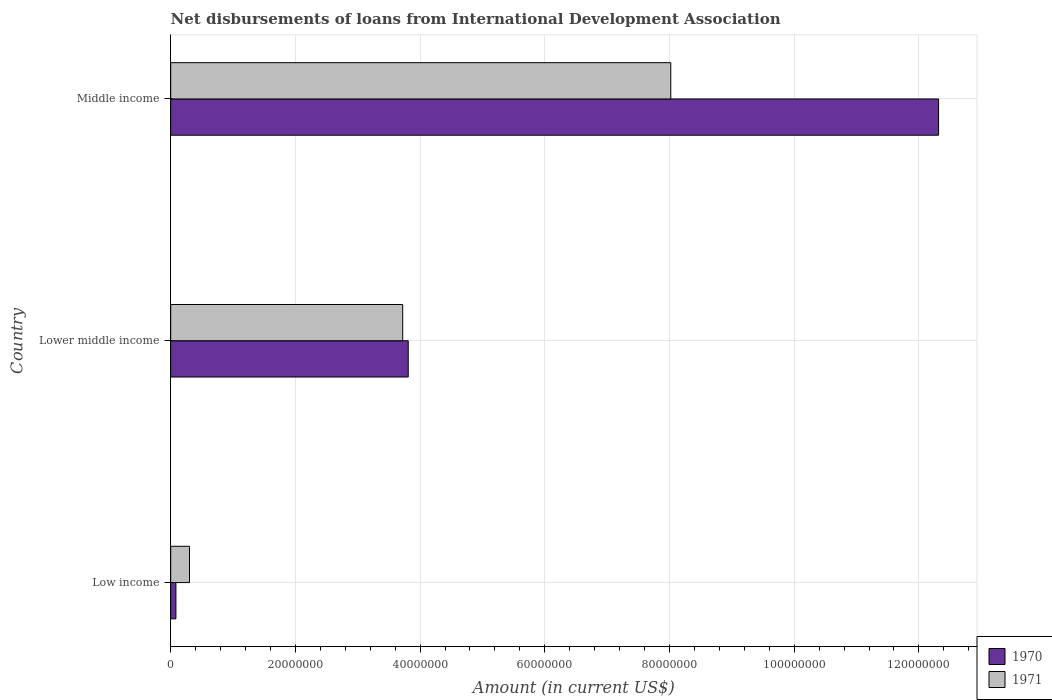How many different coloured bars are there?
Give a very brief answer. 2. How many groups of bars are there?
Your answer should be compact. 3. Are the number of bars per tick equal to the number of legend labels?
Your response must be concise. Yes. How many bars are there on the 3rd tick from the top?
Keep it short and to the point. 2. How many bars are there on the 2nd tick from the bottom?
Provide a succinct answer. 2. What is the amount of loans disbursed in 1971 in Lower middle income?
Provide a succinct answer. 3.72e+07. Across all countries, what is the maximum amount of loans disbursed in 1971?
Provide a short and direct response. 8.02e+07. Across all countries, what is the minimum amount of loans disbursed in 1970?
Provide a short and direct response. 8.35e+05. In which country was the amount of loans disbursed in 1971 maximum?
Ensure brevity in your answer.  Middle income. What is the total amount of loans disbursed in 1970 in the graph?
Your answer should be compact. 1.62e+08. What is the difference between the amount of loans disbursed in 1971 in Lower middle income and that in Middle income?
Give a very brief answer. -4.30e+07. What is the difference between the amount of loans disbursed in 1971 in Low income and the amount of loans disbursed in 1970 in Middle income?
Provide a succinct answer. -1.20e+08. What is the average amount of loans disbursed in 1971 per country?
Offer a very short reply. 4.01e+07. What is the difference between the amount of loans disbursed in 1970 and amount of loans disbursed in 1971 in Lower middle income?
Keep it short and to the point. 8.88e+05. In how many countries, is the amount of loans disbursed in 1971 greater than 40000000 US$?
Provide a succinct answer. 1. What is the ratio of the amount of loans disbursed in 1971 in Low income to that in Middle income?
Offer a very short reply. 0.04. Is the amount of loans disbursed in 1970 in Lower middle income less than that in Middle income?
Keep it short and to the point. Yes. What is the difference between the highest and the second highest amount of loans disbursed in 1971?
Ensure brevity in your answer.  4.30e+07. What is the difference between the highest and the lowest amount of loans disbursed in 1970?
Ensure brevity in your answer.  1.22e+08. In how many countries, is the amount of loans disbursed in 1970 greater than the average amount of loans disbursed in 1970 taken over all countries?
Offer a very short reply. 1. Is the sum of the amount of loans disbursed in 1970 in Low income and Middle income greater than the maximum amount of loans disbursed in 1971 across all countries?
Your answer should be compact. Yes. What does the 1st bar from the top in Middle income represents?
Give a very brief answer. 1971. How many bars are there?
Keep it short and to the point. 6. Are all the bars in the graph horizontal?
Ensure brevity in your answer.  Yes. What is the difference between two consecutive major ticks on the X-axis?
Make the answer very short. 2.00e+07. Are the values on the major ticks of X-axis written in scientific E-notation?
Your answer should be compact. No. Does the graph contain any zero values?
Provide a short and direct response. No. Does the graph contain grids?
Ensure brevity in your answer.  Yes. Where does the legend appear in the graph?
Your answer should be very brief. Bottom right. How many legend labels are there?
Offer a terse response. 2. What is the title of the graph?
Offer a terse response. Net disbursements of loans from International Development Association. What is the Amount (in current US$) of 1970 in Low income?
Provide a succinct answer. 8.35e+05. What is the Amount (in current US$) in 1971 in Low income?
Your answer should be very brief. 3.02e+06. What is the Amount (in current US$) of 1970 in Lower middle income?
Give a very brief answer. 3.81e+07. What is the Amount (in current US$) of 1971 in Lower middle income?
Make the answer very short. 3.72e+07. What is the Amount (in current US$) in 1970 in Middle income?
Offer a terse response. 1.23e+08. What is the Amount (in current US$) of 1971 in Middle income?
Give a very brief answer. 8.02e+07. Across all countries, what is the maximum Amount (in current US$) in 1970?
Offer a very short reply. 1.23e+08. Across all countries, what is the maximum Amount (in current US$) in 1971?
Provide a succinct answer. 8.02e+07. Across all countries, what is the minimum Amount (in current US$) in 1970?
Your answer should be very brief. 8.35e+05. Across all countries, what is the minimum Amount (in current US$) of 1971?
Ensure brevity in your answer.  3.02e+06. What is the total Amount (in current US$) of 1970 in the graph?
Keep it short and to the point. 1.62e+08. What is the total Amount (in current US$) of 1971 in the graph?
Your answer should be very brief. 1.20e+08. What is the difference between the Amount (in current US$) in 1970 in Low income and that in Lower middle income?
Ensure brevity in your answer.  -3.73e+07. What is the difference between the Amount (in current US$) of 1971 in Low income and that in Lower middle income?
Provide a short and direct response. -3.42e+07. What is the difference between the Amount (in current US$) in 1970 in Low income and that in Middle income?
Provide a succinct answer. -1.22e+08. What is the difference between the Amount (in current US$) in 1971 in Low income and that in Middle income?
Provide a succinct answer. -7.72e+07. What is the difference between the Amount (in current US$) of 1970 in Lower middle income and that in Middle income?
Offer a very short reply. -8.51e+07. What is the difference between the Amount (in current US$) in 1971 in Lower middle income and that in Middle income?
Ensure brevity in your answer.  -4.30e+07. What is the difference between the Amount (in current US$) in 1970 in Low income and the Amount (in current US$) in 1971 in Lower middle income?
Offer a very short reply. -3.64e+07. What is the difference between the Amount (in current US$) of 1970 in Low income and the Amount (in current US$) of 1971 in Middle income?
Provide a short and direct response. -7.94e+07. What is the difference between the Amount (in current US$) in 1970 in Lower middle income and the Amount (in current US$) in 1971 in Middle income?
Keep it short and to the point. -4.21e+07. What is the average Amount (in current US$) of 1970 per country?
Your response must be concise. 5.40e+07. What is the average Amount (in current US$) of 1971 per country?
Ensure brevity in your answer.  4.01e+07. What is the difference between the Amount (in current US$) of 1970 and Amount (in current US$) of 1971 in Low income?
Your response must be concise. -2.18e+06. What is the difference between the Amount (in current US$) of 1970 and Amount (in current US$) of 1971 in Lower middle income?
Your response must be concise. 8.88e+05. What is the difference between the Amount (in current US$) of 1970 and Amount (in current US$) of 1971 in Middle income?
Your response must be concise. 4.30e+07. What is the ratio of the Amount (in current US$) in 1970 in Low income to that in Lower middle income?
Your answer should be very brief. 0.02. What is the ratio of the Amount (in current US$) of 1971 in Low income to that in Lower middle income?
Your answer should be compact. 0.08. What is the ratio of the Amount (in current US$) of 1970 in Low income to that in Middle income?
Your response must be concise. 0.01. What is the ratio of the Amount (in current US$) in 1971 in Low income to that in Middle income?
Provide a succinct answer. 0.04. What is the ratio of the Amount (in current US$) of 1970 in Lower middle income to that in Middle income?
Offer a very short reply. 0.31. What is the ratio of the Amount (in current US$) of 1971 in Lower middle income to that in Middle income?
Your answer should be compact. 0.46. What is the difference between the highest and the second highest Amount (in current US$) in 1970?
Keep it short and to the point. 8.51e+07. What is the difference between the highest and the second highest Amount (in current US$) of 1971?
Offer a terse response. 4.30e+07. What is the difference between the highest and the lowest Amount (in current US$) in 1970?
Your response must be concise. 1.22e+08. What is the difference between the highest and the lowest Amount (in current US$) of 1971?
Keep it short and to the point. 7.72e+07. 